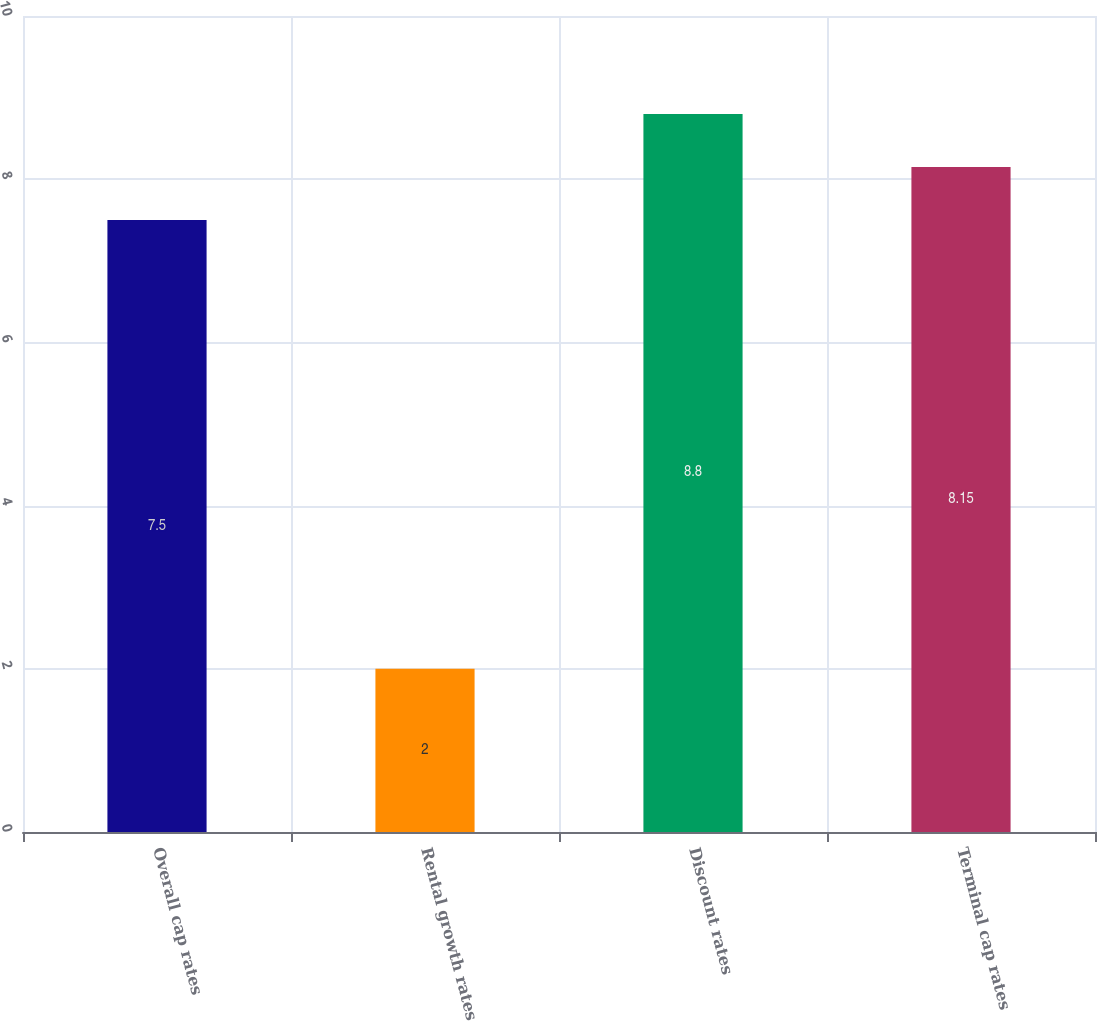<chart> <loc_0><loc_0><loc_500><loc_500><bar_chart><fcel>Overall cap rates<fcel>Rental growth rates<fcel>Discount rates<fcel>Terminal cap rates<nl><fcel>7.5<fcel>2<fcel>8.8<fcel>8.15<nl></chart> 